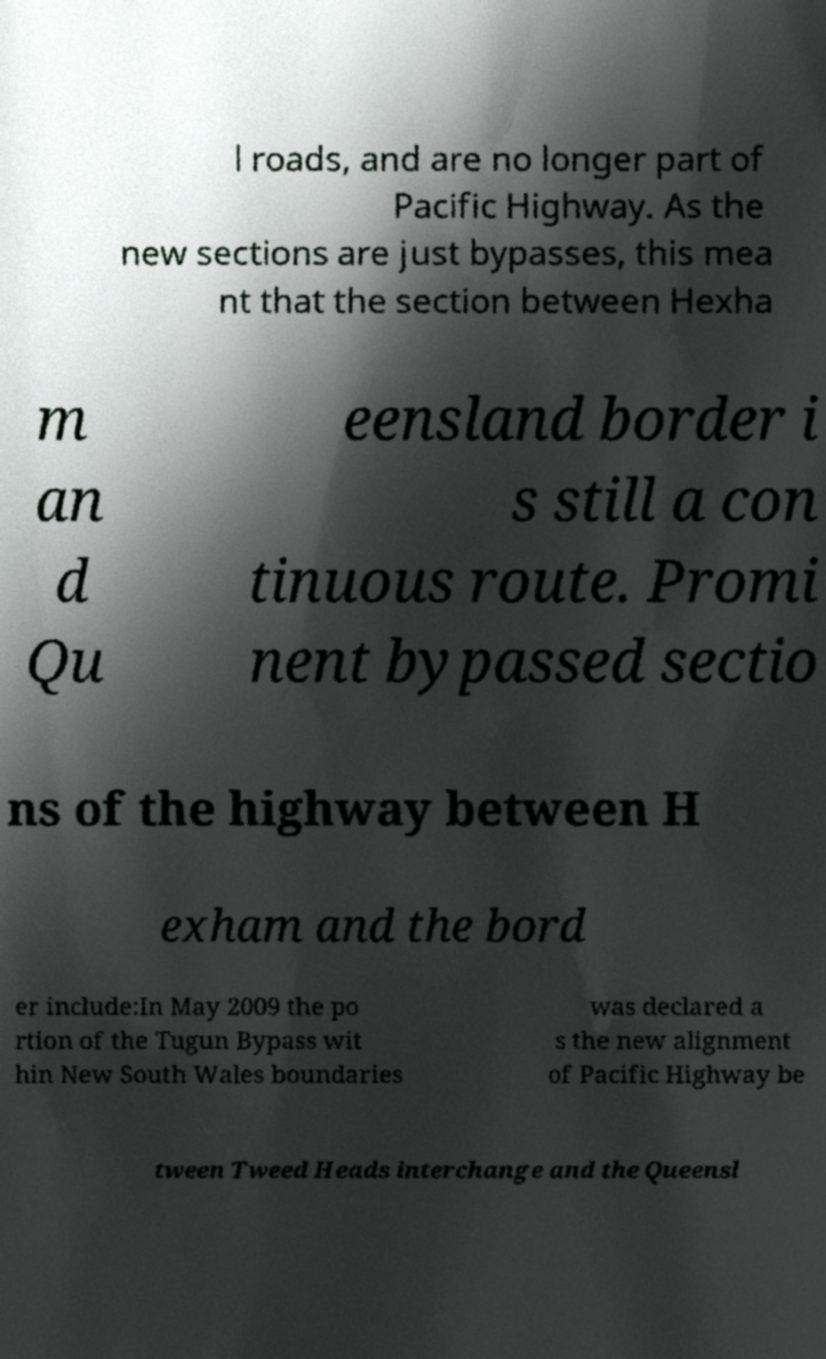Could you assist in decoding the text presented in this image and type it out clearly? l roads, and are no longer part of Pacific Highway. As the new sections are just bypasses, this mea nt that the section between Hexha m an d Qu eensland border i s still a con tinuous route. Promi nent bypassed sectio ns of the highway between H exham and the bord er include:In May 2009 the po rtion of the Tugun Bypass wit hin New South Wales boundaries was declared a s the new alignment of Pacific Highway be tween Tweed Heads interchange and the Queensl 